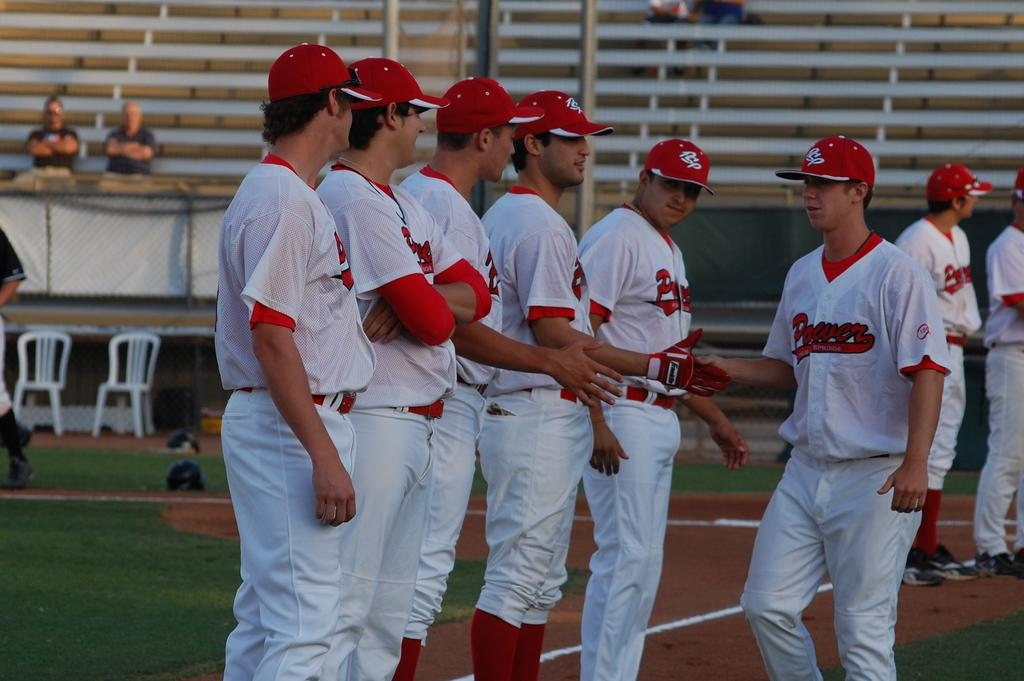<image>
Relay a brief, clear account of the picture shown. Members of the Power team are lines up as one teammate walks along and shakes their hands. 